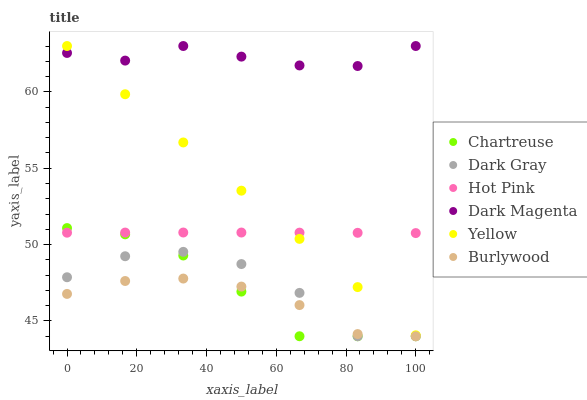Does Burlywood have the minimum area under the curve?
Answer yes or no. Yes. Does Dark Magenta have the maximum area under the curve?
Answer yes or no. Yes. Does Hot Pink have the minimum area under the curve?
Answer yes or no. No. Does Hot Pink have the maximum area under the curve?
Answer yes or no. No. Is Yellow the smoothest?
Answer yes or no. Yes. Is Dark Gray the roughest?
Answer yes or no. Yes. Is Burlywood the smoothest?
Answer yes or no. No. Is Burlywood the roughest?
Answer yes or no. No. Does Burlywood have the lowest value?
Answer yes or no. Yes. Does Hot Pink have the lowest value?
Answer yes or no. No. Does Yellow have the highest value?
Answer yes or no. Yes. Does Hot Pink have the highest value?
Answer yes or no. No. Is Burlywood less than Dark Magenta?
Answer yes or no. Yes. Is Hot Pink greater than Burlywood?
Answer yes or no. Yes. Does Hot Pink intersect Yellow?
Answer yes or no. Yes. Is Hot Pink less than Yellow?
Answer yes or no. No. Is Hot Pink greater than Yellow?
Answer yes or no. No. Does Burlywood intersect Dark Magenta?
Answer yes or no. No. 